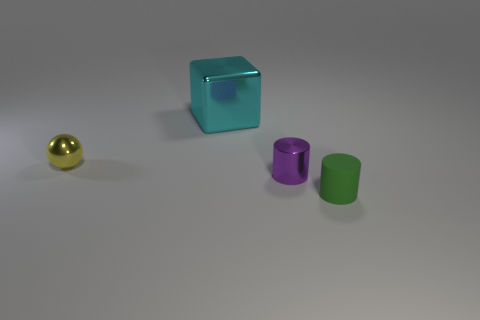How many cylinders are small purple metallic things or cyan objects? In the image, there are two cylinders: one is a small purple metallic cylinder, and the other is a small green cylinder. There are no cyan cylinders, but there is one large cyan cube. So, to directly answer your question, there is one small purple metallic cylinder, and no cylinders are cyan objects. 